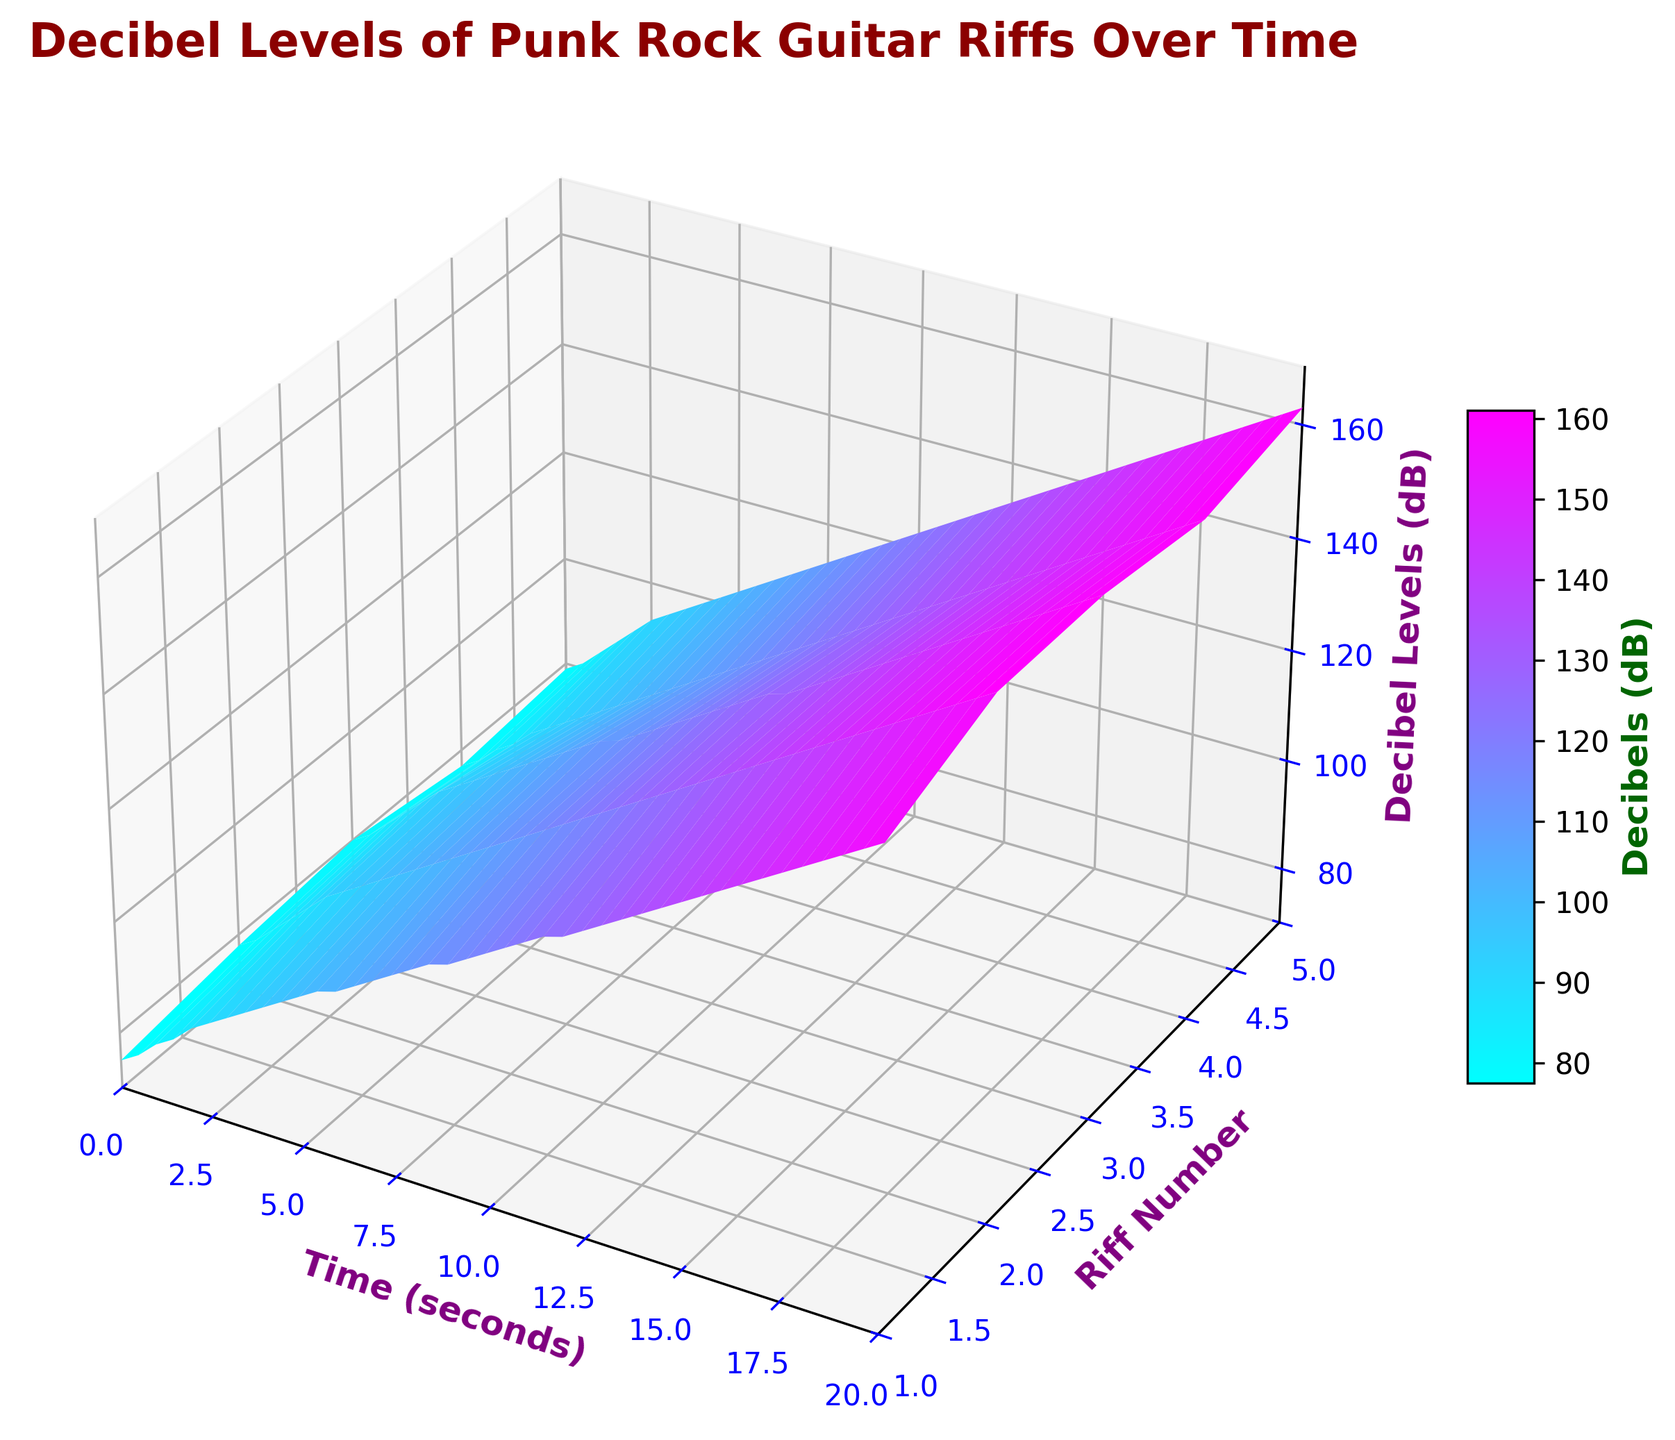Which riff has the highest decibel level at the 10-second mark? To determine this, locate the time axis at 10 seconds and check the decibel levels for all riffs at this time point. Among Riff 1, Riff 2, Riff 3, Riff 4, and Riff 5, Riff 3 has the highest decibel level.
Answer: Riff 3 At which time does Riff 1 reach 130 dB? Identify the section of the surface where Riff 1 (Riff Number 1) intersects with the decibel level of 130 dB. Track it horizontally to find the corresponding time coordinate. Riff 1 reaches 130 dB around 14 seconds.
Answer: 14 seconds From the beginning to the 5-second mark, which riff's decibel level increases the fastest? Assess the slope of the surfaces between the start (0 seconds) and the 5-second mark for each riff. The steepest slope indicates the fastest increase. Riff 3's decibel level shows the steepest climb.
Answer: Riff 3 What's the average decibel level for Riff 5 between 5 and 10 seconds? To find this, add the decibel levels of Riff 5 at 5, 6, 7, 8, 9, and 10 seconds, then divide by the number of points (6). Decibel levels are 103, 105, 107, 109, 111, and 113, respectively. Average = (103 + 105 + 107 + 109 + 111 + 113) / 6 = 108 dB.
Answer: 108 dB Compare the overall shape and gradient of the surfaces for Riff 2 and Riff 4. Which one shows a steeper increase in volume? By examining the surfaces for Riff 2 and Riff 4, you can see that Riff 2 shows a steeper gradient, implying a faster increase in volume over time.
Answer: Riff 2 Which riff shows the least variability in decibel levels over the entire time period? By observing the smoothness and uniformity of the surfaces, Riff 1 displays the least fluctuation compared to the others, indicating the least variability.
Answer: Riff 1 At the 15-second mark, how much louder is Riff 5 compared to Riff 1? At 15 seconds, the decibel level for Riff 5 is 143 dB and for Riff 1 is 134 dB. The difference in decibel levels can be calculated as 143 - 134.
Answer: 9 dB What is the color of the surface representing the maximum decibel level (dB) in the plot? Locate the highest point on the surface plot (which represents the maximum decibel level) and observe its color. The color corresponding to the highest decibel level is in the red part of the spectrum, as indicated by the color bar.
Answer: Red 